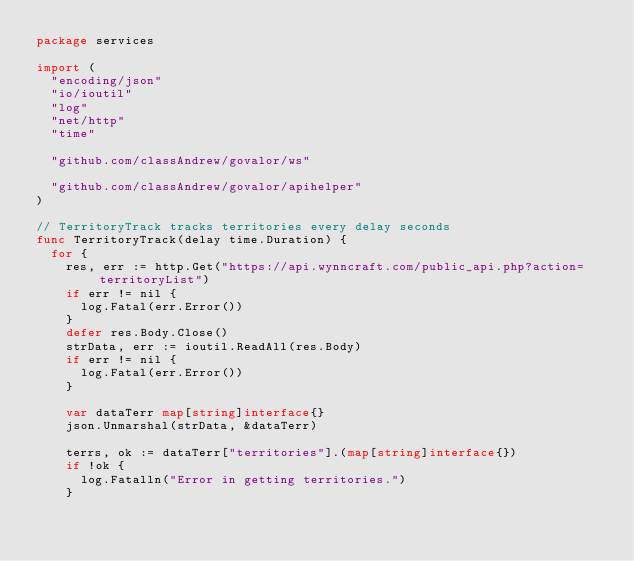<code> <loc_0><loc_0><loc_500><loc_500><_Go_>package services

import (
	"encoding/json"
	"io/ioutil"
	"log"
	"net/http"
	"time"

	"github.com/classAndrew/govalor/ws"

	"github.com/classAndrew/govalor/apihelper"
)

// TerritoryTrack tracks territories every delay seconds
func TerritoryTrack(delay time.Duration) {
	for {
		res, err := http.Get("https://api.wynncraft.com/public_api.php?action=territoryList")
		if err != nil {
			log.Fatal(err.Error())
		}
		defer res.Body.Close()
		strData, err := ioutil.ReadAll(res.Body)
		if err != nil {
			log.Fatal(err.Error())
		}

		var dataTerr map[string]interface{}
		json.Unmarshal(strData, &dataTerr)

		terrs, ok := dataTerr["territories"].(map[string]interface{})
		if !ok {
			log.Fatalln("Error in getting territories.")
		}
</code> 